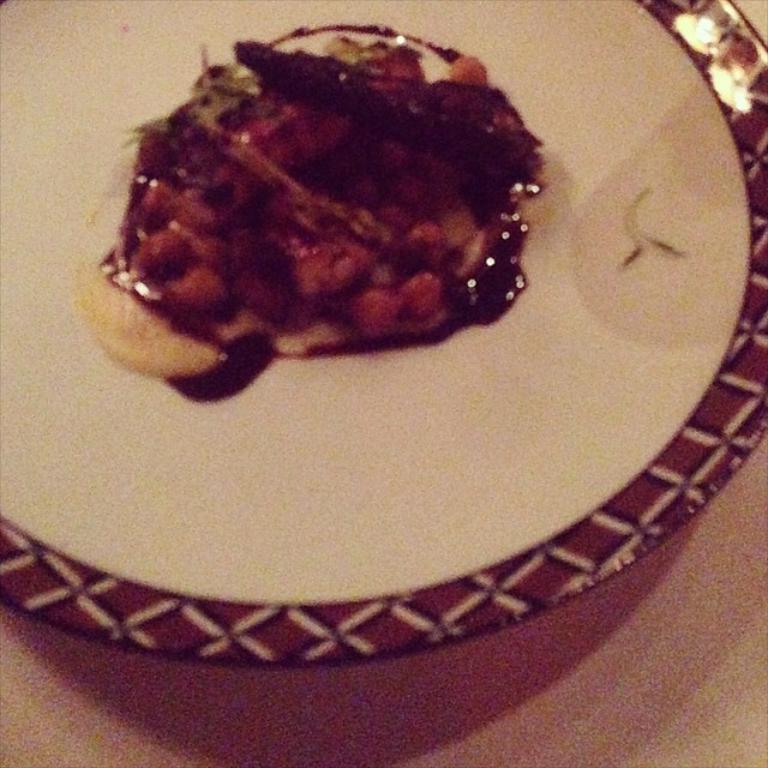Please provide a concise description of this image. In this picture we can see a plate here, there is some food present in the plate, at the bottom there is a surface. 